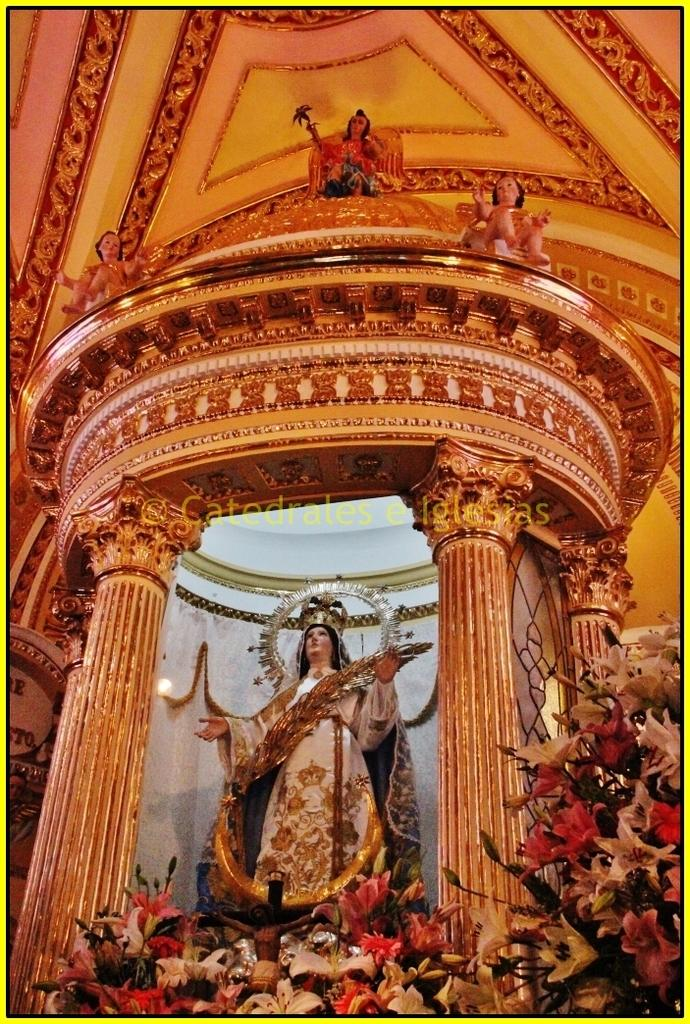What type of objects can be seen in the image? There are statues, pillars, and flowers in the image. What architectural feature is present in the image? There is a wall in the image. Are there any letters or symbols visible in the image? Yes, there are some alphabet on the left side of the image. Can you see any signs of shame in the image? There is no indication of shame in the image, as it features statues, pillars, flowers, a wall, and some alphabet. Is there a rifle visible in the image? No, there is no rifle present in the image. 